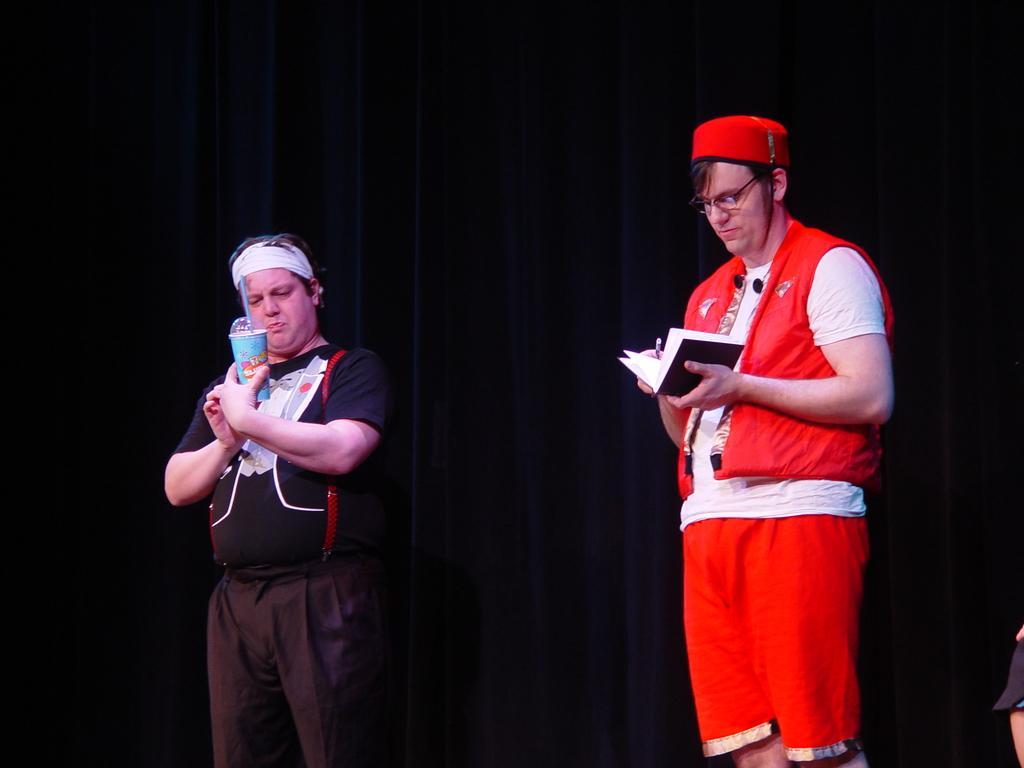Please provide a concise description of this image. In this image two persons are standing. The person in the right is holding a book and pen wearing red dress and cap. The person in the left is holding a glass wearing black dress. In the background there are curtains. 